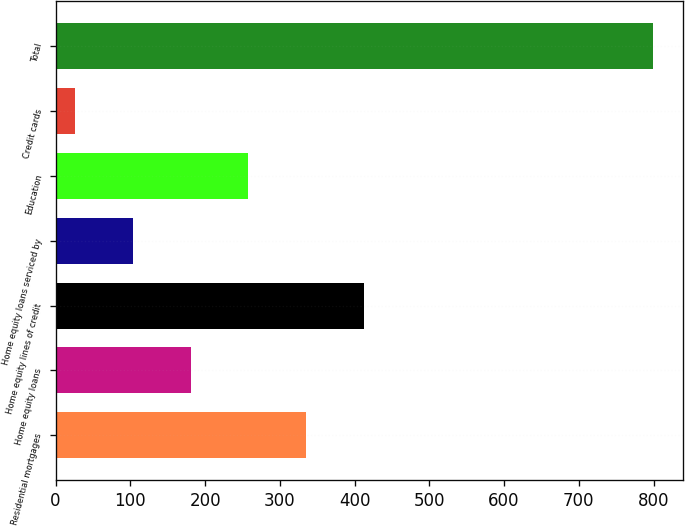Convert chart to OTSL. <chart><loc_0><loc_0><loc_500><loc_500><bar_chart><fcel>Residential mortgages<fcel>Home equity loans<fcel>Home equity lines of credit<fcel>Home equity loans serviced by<fcel>Education<fcel>Credit cards<fcel>Total<nl><fcel>335.2<fcel>180.6<fcel>412.5<fcel>103.3<fcel>257.9<fcel>26<fcel>799<nl></chart> 